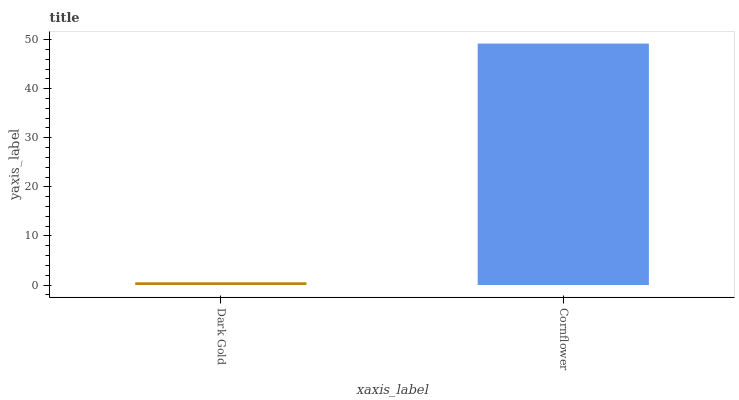Is Cornflower the minimum?
Answer yes or no. No. Is Cornflower greater than Dark Gold?
Answer yes or no. Yes. Is Dark Gold less than Cornflower?
Answer yes or no. Yes. Is Dark Gold greater than Cornflower?
Answer yes or no. No. Is Cornflower less than Dark Gold?
Answer yes or no. No. Is Cornflower the high median?
Answer yes or no. Yes. Is Dark Gold the low median?
Answer yes or no. Yes. Is Dark Gold the high median?
Answer yes or no. No. Is Cornflower the low median?
Answer yes or no. No. 